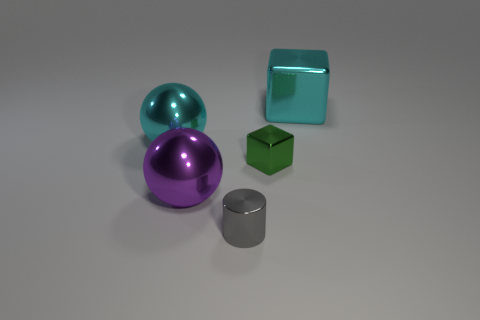What color is the metallic sphere to the right of the cyan metallic thing on the left side of the large thing right of the purple sphere?
Provide a short and direct response. Purple. Is the size of the gray object the same as the cyan object that is on the left side of the green cube?
Your response must be concise. No. How many things are small cylinders or large things?
Offer a very short reply. 4. Are there any other big spheres made of the same material as the large cyan ball?
Your response must be concise. Yes. The metallic ball that is the same color as the big cube is what size?
Offer a terse response. Large. There is a large metallic thing that is in front of the big cyan metallic thing on the left side of the gray metal cylinder; what color is it?
Provide a succinct answer. Purple. Does the green metal object have the same size as the gray thing?
Make the answer very short. Yes. How many cubes are gray metallic objects or large purple things?
Provide a succinct answer. 0. There is a large cyan thing to the left of the large purple shiny object; how many purple objects are in front of it?
Keep it short and to the point. 1. Do the gray object and the big purple object have the same shape?
Offer a terse response. No. 